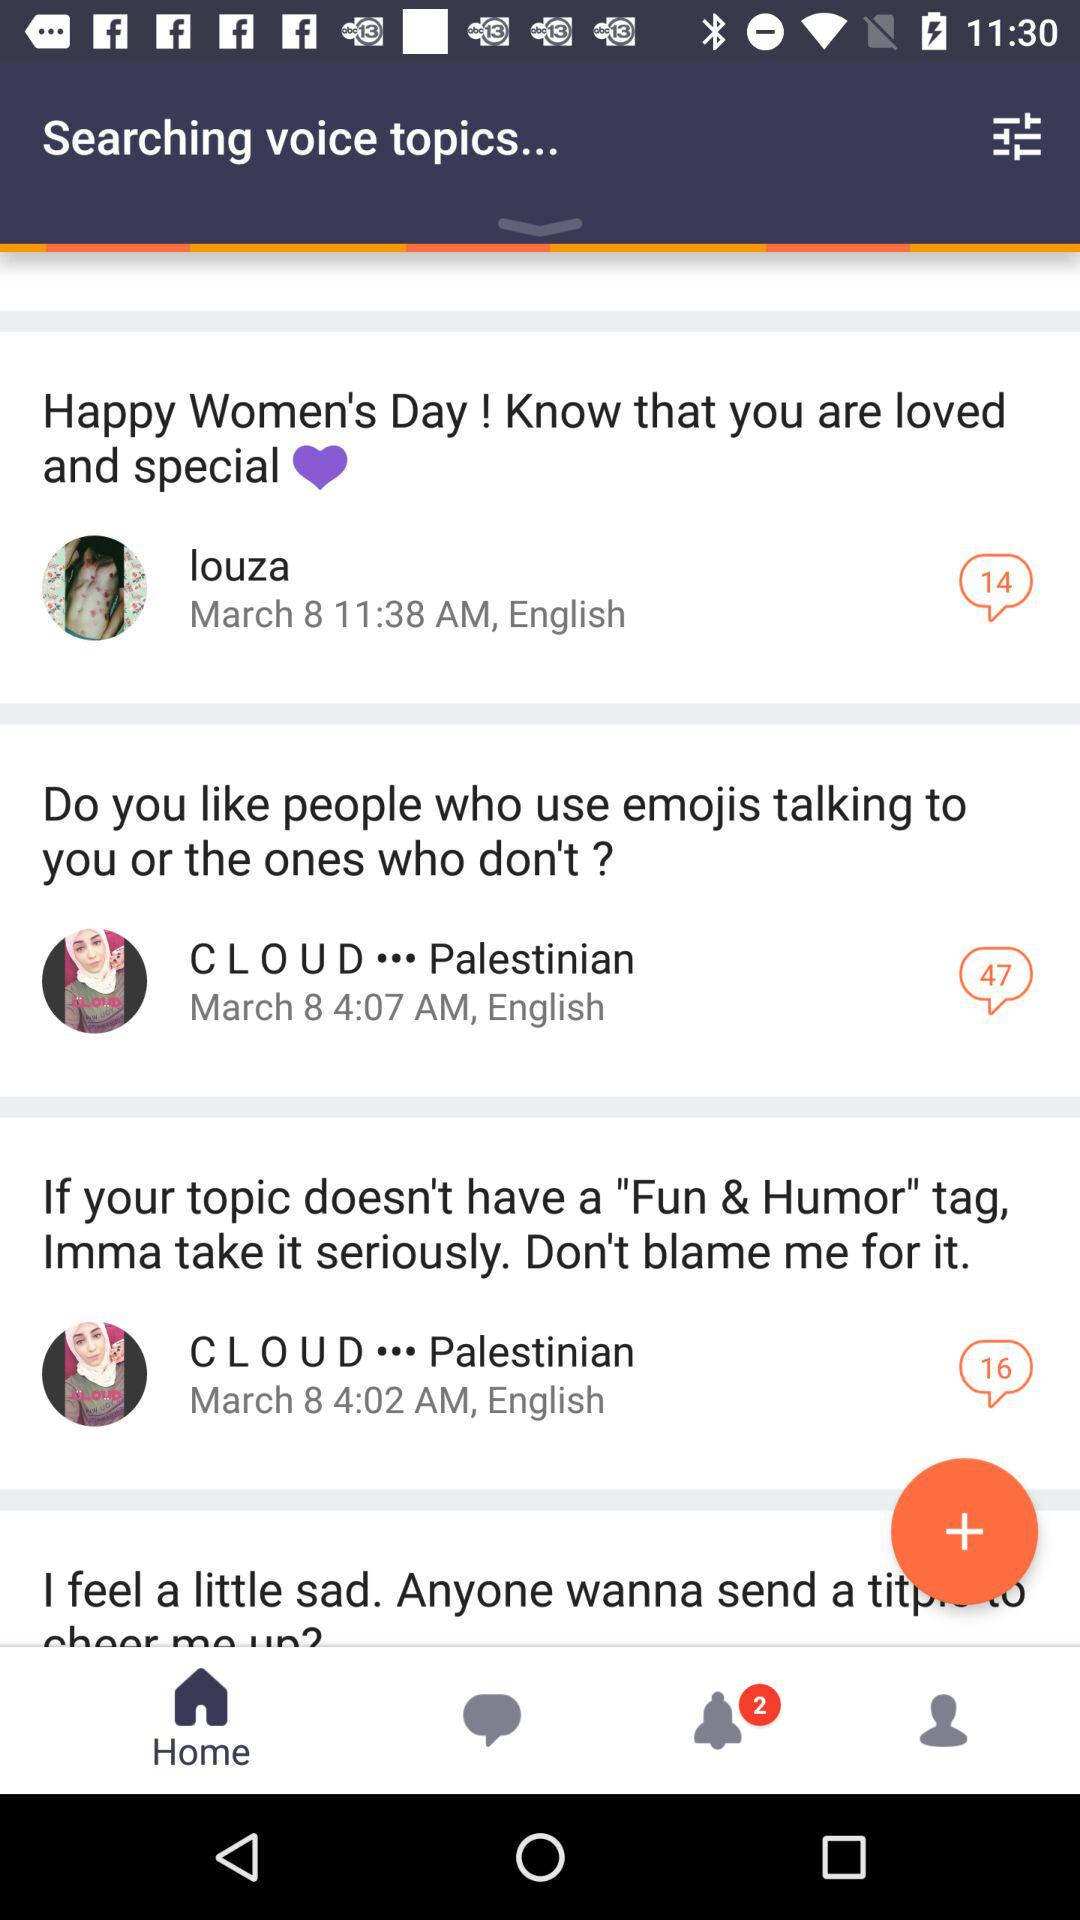When did "C L O U D" from Palestine post about people who use emojis while talking? The "C L O U D" from Palestine posted about people who use emojis while talking on March 8 at 4:07 AM. 